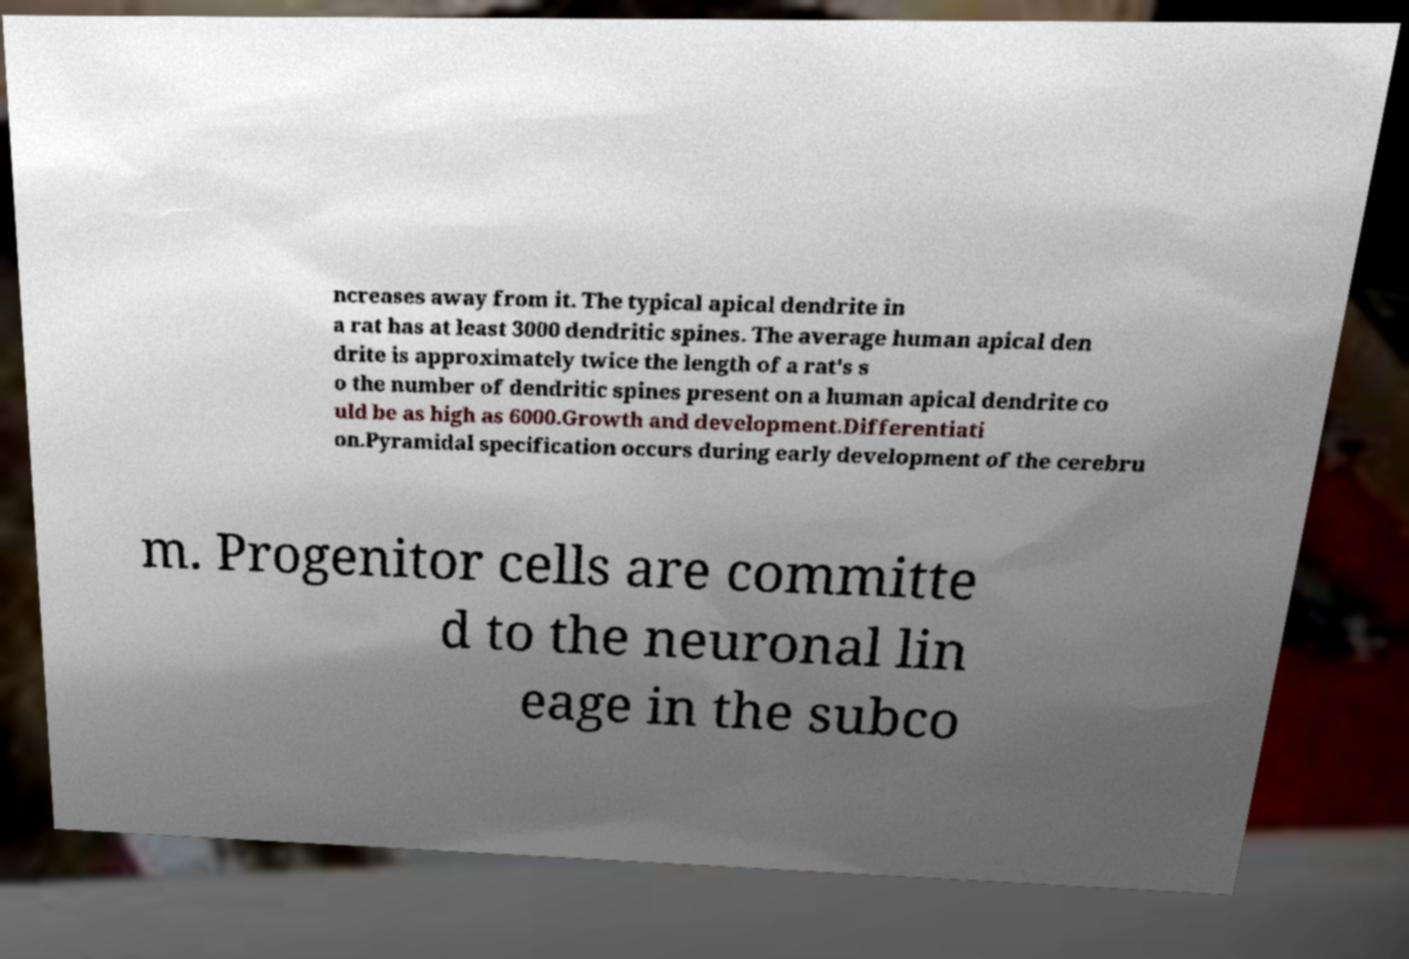Can you accurately transcribe the text from the provided image for me? ncreases away from it. The typical apical dendrite in a rat has at least 3000 dendritic spines. The average human apical den drite is approximately twice the length of a rat's s o the number of dendritic spines present on a human apical dendrite co uld be as high as 6000.Growth and development.Differentiati on.Pyramidal specification occurs during early development of the cerebru m. Progenitor cells are committe d to the neuronal lin eage in the subco 